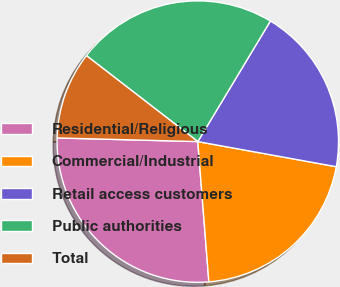Convert chart. <chart><loc_0><loc_0><loc_500><loc_500><pie_chart><fcel>Residential/Religious<fcel>Commercial/Industrial<fcel>Retail access customers<fcel>Public authorities<fcel>Total<nl><fcel>26.66%<fcel>20.89%<fcel>19.23%<fcel>23.16%<fcel>10.05%<nl></chart> 